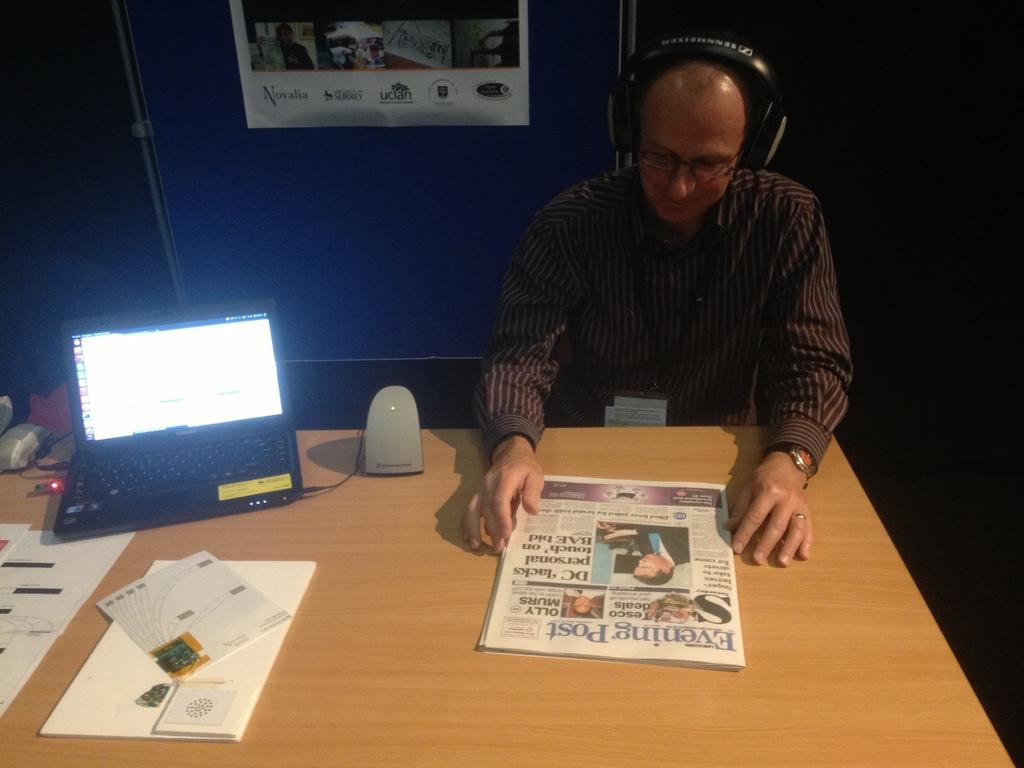<image>
Create a compact narrative representing the image presented. A man wearing headphones is reading the Evening Post. 